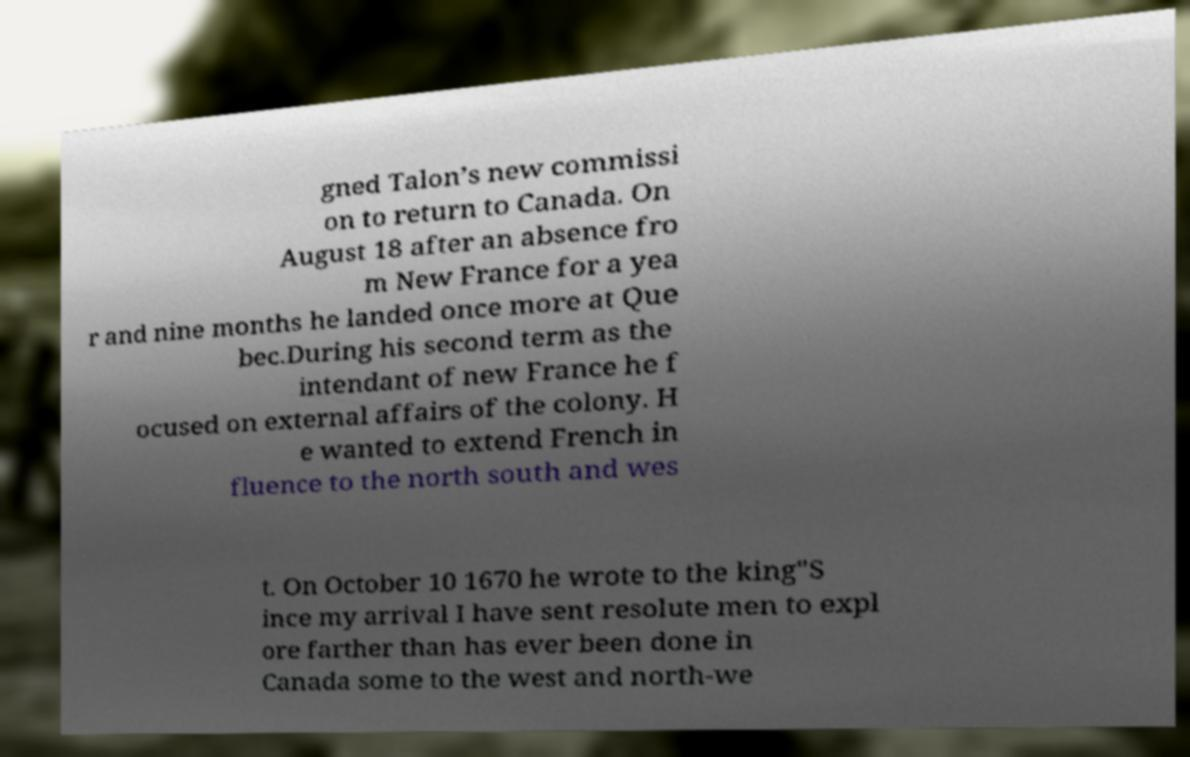I need the written content from this picture converted into text. Can you do that? gned Talon’s new commissi on to return to Canada. On August 18 after an absence fro m New France for a yea r and nine months he landed once more at Que bec.During his second term as the intendant of new France he f ocused on external affairs of the colony. H e wanted to extend French in fluence to the north south and wes t. On October 10 1670 he wrote to the king"S ince my arrival I have sent resolute men to expl ore farther than has ever been done in Canada some to the west and north-we 